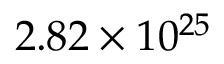Convert formula to latex. <formula><loc_0><loc_0><loc_500><loc_500>2 . 8 2 \times 1 0 ^ { 2 5 }</formula> 